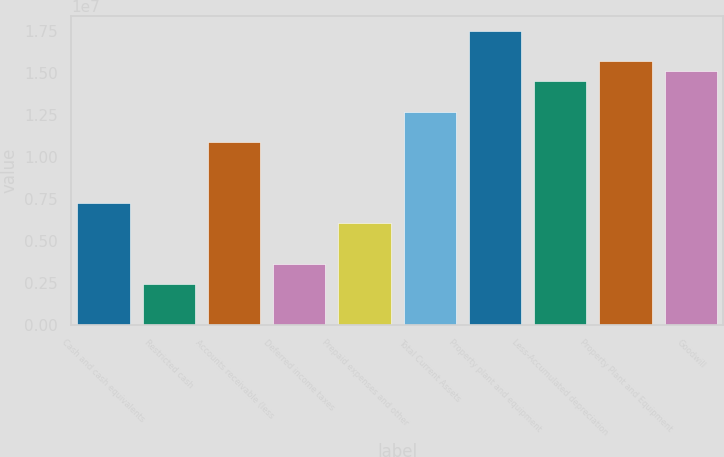Convert chart. <chart><loc_0><loc_0><loc_500><loc_500><bar_chart><fcel>Cash and cash equivalents<fcel>Restricted cash<fcel>Accounts receivable (less<fcel>Deferred income taxes<fcel>Prepaid expenses and other<fcel>Total Current Assets<fcel>Property plant and equipment<fcel>Less-Accumulated depreciation<fcel>Property Plant and Equipment<fcel>Goodwill<nl><fcel>7.24917e+06<fcel>2.41754e+06<fcel>1.08729e+07<fcel>3.62544e+06<fcel>6.04126e+06<fcel>1.26847e+07<fcel>1.75164e+07<fcel>1.44966e+07<fcel>1.57045e+07<fcel>1.51006e+07<nl></chart> 